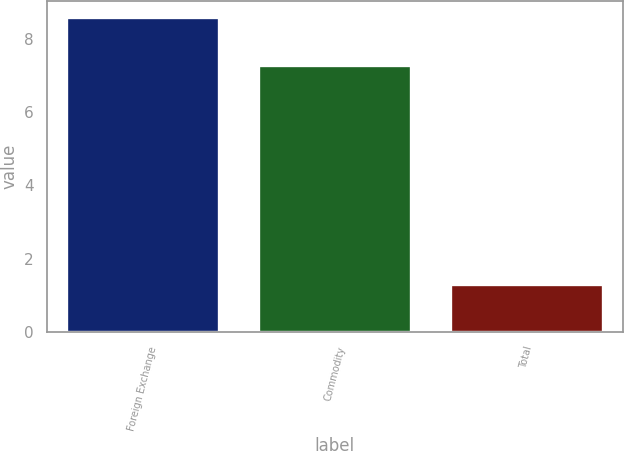Convert chart to OTSL. <chart><loc_0><loc_0><loc_500><loc_500><bar_chart><fcel>Foreign Exchange<fcel>Commodity<fcel>Total<nl><fcel>8.6<fcel>7.3<fcel>1.3<nl></chart> 